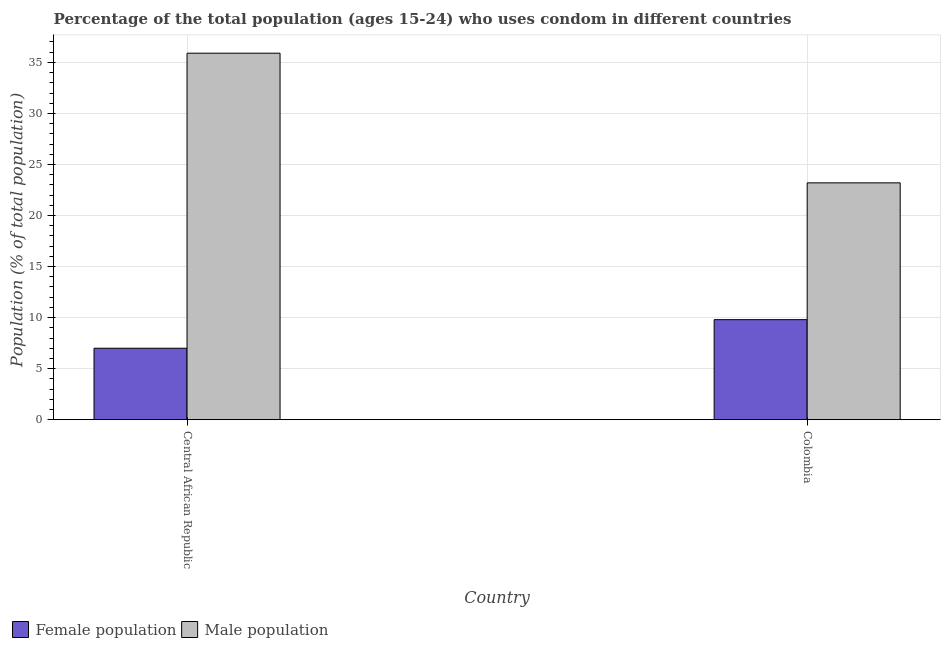How many bars are there on the 2nd tick from the right?
Provide a succinct answer. 2. What is the label of the 1st group of bars from the left?
Offer a terse response. Central African Republic. What is the female population in Colombia?
Offer a very short reply. 9.8. Across all countries, what is the maximum female population?
Offer a very short reply. 9.8. In which country was the female population maximum?
Your answer should be compact. Colombia. In which country was the female population minimum?
Your answer should be very brief. Central African Republic. What is the total male population in the graph?
Offer a very short reply. 59.1. What is the difference between the male population in Central African Republic and the female population in Colombia?
Ensure brevity in your answer.  26.1. What is the average male population per country?
Make the answer very short. 29.55. What is the difference between the male population and female population in Central African Republic?
Your answer should be compact. 28.9. What is the ratio of the female population in Central African Republic to that in Colombia?
Provide a short and direct response. 0.71. What does the 2nd bar from the left in Central African Republic represents?
Keep it short and to the point. Male population. What does the 1st bar from the right in Colombia represents?
Offer a terse response. Male population. What is the difference between two consecutive major ticks on the Y-axis?
Offer a terse response. 5. Are the values on the major ticks of Y-axis written in scientific E-notation?
Offer a very short reply. No. Does the graph contain any zero values?
Offer a terse response. No. Where does the legend appear in the graph?
Offer a terse response. Bottom left. How many legend labels are there?
Give a very brief answer. 2. What is the title of the graph?
Your answer should be very brief. Percentage of the total population (ages 15-24) who uses condom in different countries. Does "Primary completion rate" appear as one of the legend labels in the graph?
Provide a short and direct response. No. What is the label or title of the Y-axis?
Your response must be concise. Population (% of total population) . What is the Population (% of total population)  of Female population in Central African Republic?
Offer a very short reply. 7. What is the Population (% of total population)  of Male population in Central African Republic?
Offer a terse response. 35.9. What is the Population (% of total population)  in Female population in Colombia?
Offer a very short reply. 9.8. What is the Population (% of total population)  of Male population in Colombia?
Keep it short and to the point. 23.2. Across all countries, what is the maximum Population (% of total population)  in Male population?
Keep it short and to the point. 35.9. Across all countries, what is the minimum Population (% of total population)  of Female population?
Give a very brief answer. 7. Across all countries, what is the minimum Population (% of total population)  of Male population?
Provide a short and direct response. 23.2. What is the total Population (% of total population)  of Male population in the graph?
Make the answer very short. 59.1. What is the difference between the Population (% of total population)  of Female population in Central African Republic and the Population (% of total population)  of Male population in Colombia?
Make the answer very short. -16.2. What is the average Population (% of total population)  in Female population per country?
Keep it short and to the point. 8.4. What is the average Population (% of total population)  of Male population per country?
Provide a short and direct response. 29.55. What is the difference between the Population (% of total population)  in Female population and Population (% of total population)  in Male population in Central African Republic?
Give a very brief answer. -28.9. What is the ratio of the Population (% of total population)  in Female population in Central African Republic to that in Colombia?
Provide a short and direct response. 0.71. What is the ratio of the Population (% of total population)  in Male population in Central African Republic to that in Colombia?
Provide a short and direct response. 1.55. What is the difference between the highest and the second highest Population (% of total population)  in Female population?
Your answer should be compact. 2.8. What is the difference between the highest and the second highest Population (% of total population)  in Male population?
Provide a short and direct response. 12.7. What is the difference between the highest and the lowest Population (% of total population)  of Female population?
Your answer should be very brief. 2.8. What is the difference between the highest and the lowest Population (% of total population)  of Male population?
Ensure brevity in your answer.  12.7. 